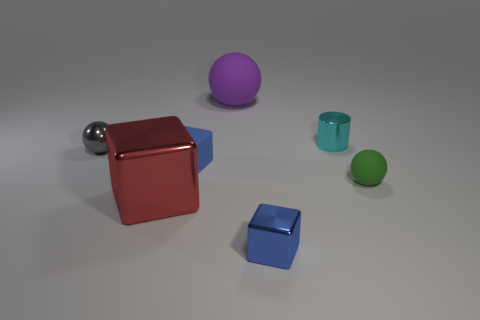Subtract all metallic spheres. How many spheres are left? 2 Subtract 1 cubes. How many cubes are left? 2 Subtract all blue balls. How many blue blocks are left? 2 Add 2 large blue objects. How many objects exist? 9 Add 2 purple things. How many purple things are left? 3 Add 6 rubber blocks. How many rubber blocks exist? 7 Subtract 0 gray cylinders. How many objects are left? 7 Subtract all cylinders. How many objects are left? 6 Subtract all red objects. Subtract all small matte balls. How many objects are left? 5 